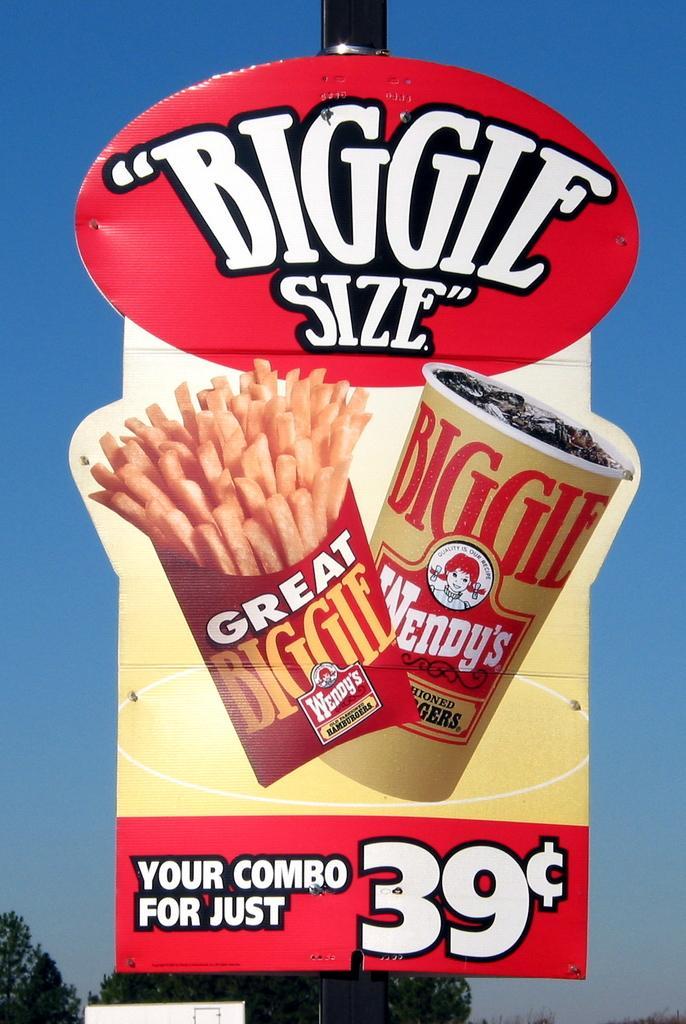Please provide a concise description of this image. In this picture we can see a board, there are pictures of food and some text on the board, in the background there are trees, we can see the sky at the top of the picture. 